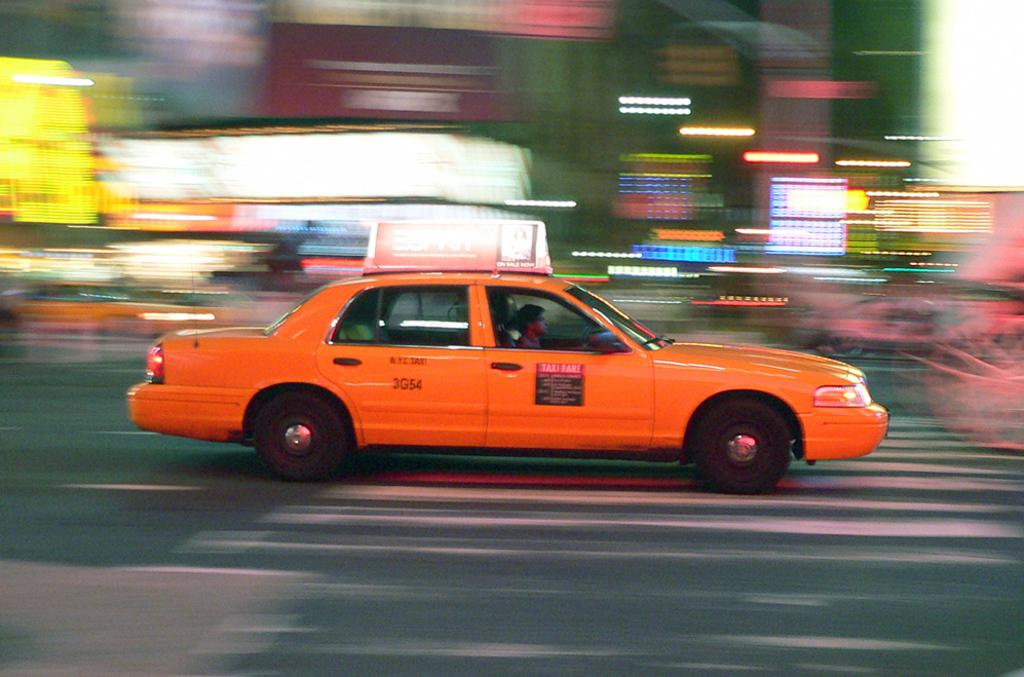<image>
Write a terse but informative summary of the picture. An orange N.Y.C. Taxi with 3G54 on its back door. 